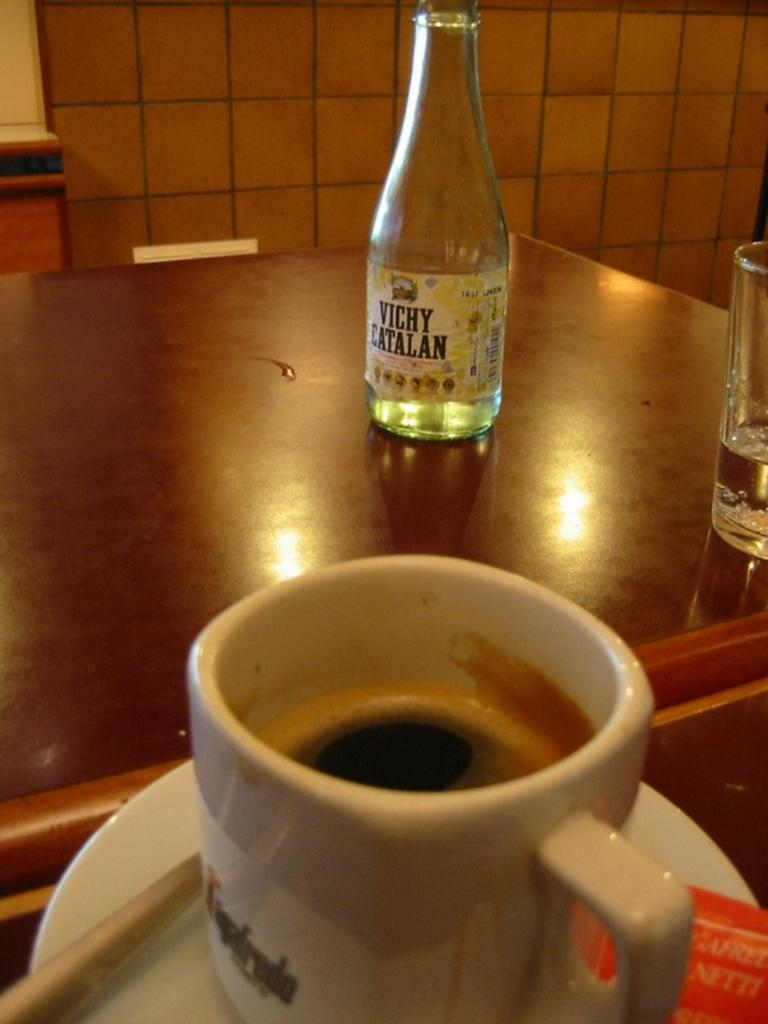What type of container is on the table in the image? There is a bottle on the table in the image. What other type of container is on the table? There is a glass on the table in the image. Are there any other types of containers on the table? Yes, there is a cup on the table in the image. Is there any additional tableware on the table? Yes, there is a saucer on the table in the image. What direction is the animal facing in the image? There is no animal present in the image. How many curves can be seen in the image? There are no curves visible in the image; it features a table with containers on it. 